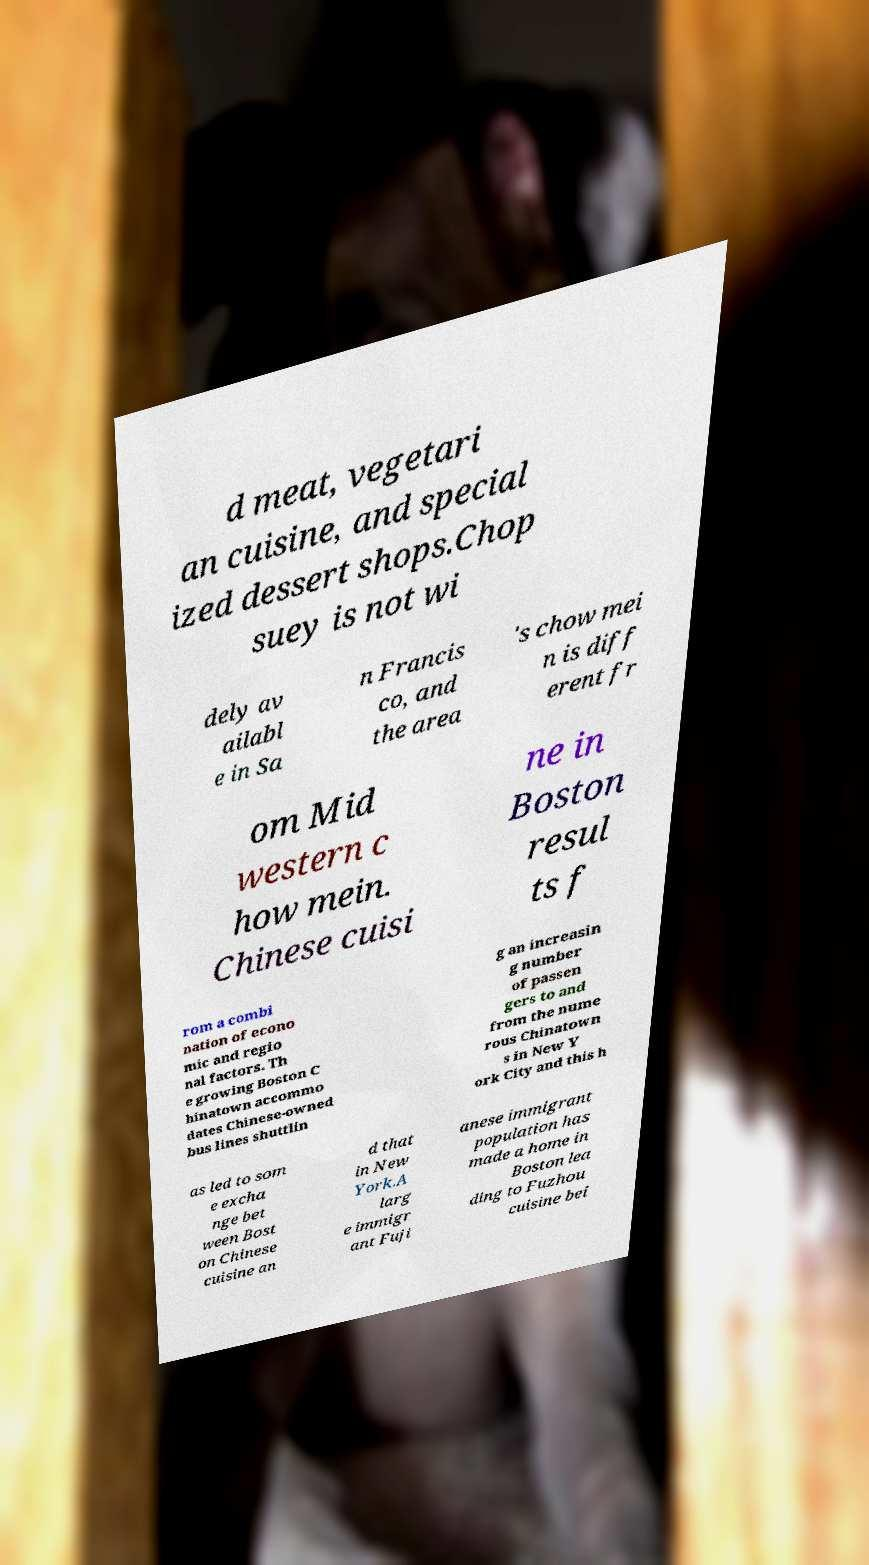Please identify and transcribe the text found in this image. d meat, vegetari an cuisine, and special ized dessert shops.Chop suey is not wi dely av ailabl e in Sa n Francis co, and the area 's chow mei n is diff erent fr om Mid western c how mein. Chinese cuisi ne in Boston resul ts f rom a combi nation of econo mic and regio nal factors. Th e growing Boston C hinatown accommo dates Chinese-owned bus lines shuttlin g an increasin g number of passen gers to and from the nume rous Chinatown s in New Y ork City and this h as led to som e excha nge bet ween Bost on Chinese cuisine an d that in New York.A larg e immigr ant Fuji anese immigrant population has made a home in Boston lea ding to Fuzhou cuisine bei 